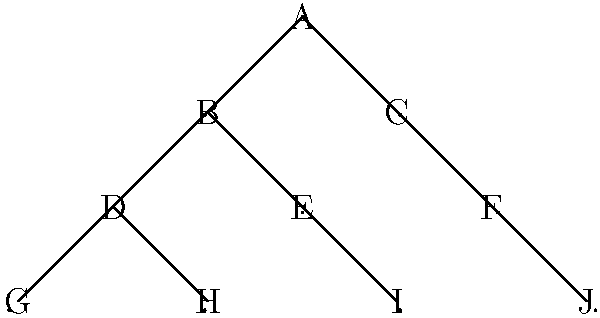In a historical fiction novel set in a medieval kingdom, you encounter a royal family tree represented as a graph. Each node represents a family member, and edges represent parent-child relationships. Given the graph above, what is the maximum number of generations represented in this royal family tree? To determine the maximum number of generations in this royal family tree, we need to find the longest path from the root node to any leaf node. Let's analyze the graph step-by-step:

1. Node A is the root of the tree, representing the oldest generation.

2. We can see three main branches stemming from A:
   - A → B → D → G
   - A → B → D → H
   - A → B → E → I
   - A → C → F → J

3. Let's count the generations for each branch:
   - A → B → D → G: 4 generations
   - A → B → D → H: 4 generations
   - A → B → E → I: 4 generations
   - A → C → F → J: 4 generations

4. The longest path in the tree has 4 nodes, which represents 4 generations.

In graph theory terms, we have found the height of the tree, which is the length of the longest path from the root to a leaf node. This height represents the maximum number of generations in the royal family tree.
Answer: 4 generations 